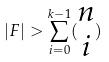Convert formula to latex. <formula><loc_0><loc_0><loc_500><loc_500>| F | > \sum _ { i = 0 } ^ { k - 1 } ( \begin{matrix} n \\ i \end{matrix} )</formula> 